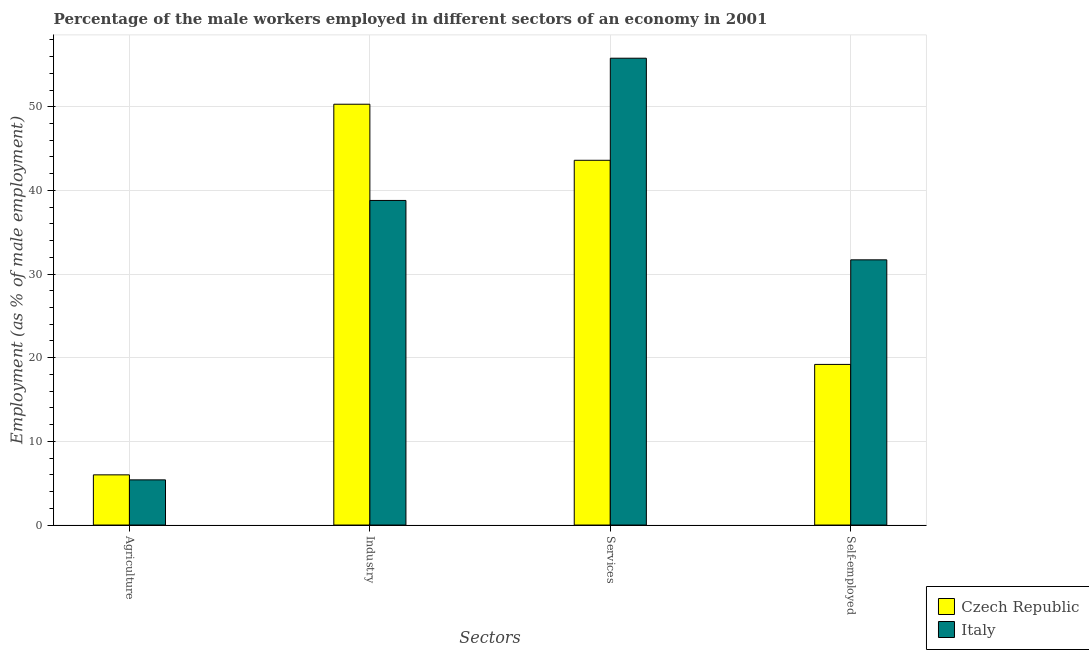How many different coloured bars are there?
Your answer should be very brief. 2. How many groups of bars are there?
Your response must be concise. 4. Are the number of bars per tick equal to the number of legend labels?
Keep it short and to the point. Yes. Are the number of bars on each tick of the X-axis equal?
Your response must be concise. Yes. How many bars are there on the 4th tick from the left?
Your answer should be very brief. 2. What is the label of the 2nd group of bars from the left?
Your answer should be very brief. Industry. What is the percentage of male workers in services in Italy?
Provide a succinct answer. 55.8. Across all countries, what is the maximum percentage of self employed male workers?
Offer a terse response. 31.7. Across all countries, what is the minimum percentage of male workers in agriculture?
Provide a short and direct response. 5.4. In which country was the percentage of male workers in services maximum?
Ensure brevity in your answer.  Italy. In which country was the percentage of male workers in agriculture minimum?
Your answer should be very brief. Italy. What is the total percentage of male workers in services in the graph?
Provide a succinct answer. 99.4. What is the difference between the percentage of male workers in industry in Italy and that in Czech Republic?
Your response must be concise. -11.5. What is the difference between the percentage of male workers in agriculture in Italy and the percentage of self employed male workers in Czech Republic?
Your answer should be very brief. -13.8. What is the average percentage of male workers in services per country?
Make the answer very short. 49.7. What is the difference between the percentage of male workers in industry and percentage of self employed male workers in Italy?
Provide a short and direct response. 7.1. In how many countries, is the percentage of male workers in services greater than 24 %?
Offer a terse response. 2. What is the ratio of the percentage of male workers in industry in Czech Republic to that in Italy?
Your response must be concise. 1.3. Is the percentage of male workers in agriculture in Czech Republic less than that in Italy?
Your response must be concise. No. Is the difference between the percentage of self employed male workers in Czech Republic and Italy greater than the difference between the percentage of male workers in services in Czech Republic and Italy?
Ensure brevity in your answer.  No. What is the difference between the highest and the second highest percentage of male workers in services?
Provide a short and direct response. 12.2. What is the difference between the highest and the lowest percentage of male workers in industry?
Offer a very short reply. 11.5. In how many countries, is the percentage of self employed male workers greater than the average percentage of self employed male workers taken over all countries?
Make the answer very short. 1. What does the 1st bar from the left in Industry represents?
Make the answer very short. Czech Republic. Is it the case that in every country, the sum of the percentage of male workers in agriculture and percentage of male workers in industry is greater than the percentage of male workers in services?
Your answer should be compact. No. How many bars are there?
Offer a very short reply. 8. Are all the bars in the graph horizontal?
Provide a short and direct response. No. How many countries are there in the graph?
Keep it short and to the point. 2. What is the difference between two consecutive major ticks on the Y-axis?
Your answer should be very brief. 10. Does the graph contain any zero values?
Your response must be concise. No. How are the legend labels stacked?
Offer a very short reply. Vertical. What is the title of the graph?
Keep it short and to the point. Percentage of the male workers employed in different sectors of an economy in 2001. Does "St. Lucia" appear as one of the legend labels in the graph?
Make the answer very short. No. What is the label or title of the X-axis?
Give a very brief answer. Sectors. What is the label or title of the Y-axis?
Your answer should be very brief. Employment (as % of male employment). What is the Employment (as % of male employment) of Italy in Agriculture?
Provide a succinct answer. 5.4. What is the Employment (as % of male employment) of Czech Republic in Industry?
Keep it short and to the point. 50.3. What is the Employment (as % of male employment) in Italy in Industry?
Offer a terse response. 38.8. What is the Employment (as % of male employment) in Czech Republic in Services?
Provide a short and direct response. 43.6. What is the Employment (as % of male employment) of Italy in Services?
Offer a terse response. 55.8. What is the Employment (as % of male employment) of Czech Republic in Self-employed?
Offer a very short reply. 19.2. What is the Employment (as % of male employment) in Italy in Self-employed?
Keep it short and to the point. 31.7. Across all Sectors, what is the maximum Employment (as % of male employment) of Czech Republic?
Offer a very short reply. 50.3. Across all Sectors, what is the maximum Employment (as % of male employment) in Italy?
Make the answer very short. 55.8. Across all Sectors, what is the minimum Employment (as % of male employment) in Italy?
Offer a terse response. 5.4. What is the total Employment (as % of male employment) in Czech Republic in the graph?
Provide a succinct answer. 119.1. What is the total Employment (as % of male employment) in Italy in the graph?
Ensure brevity in your answer.  131.7. What is the difference between the Employment (as % of male employment) in Czech Republic in Agriculture and that in Industry?
Provide a short and direct response. -44.3. What is the difference between the Employment (as % of male employment) of Italy in Agriculture and that in Industry?
Offer a very short reply. -33.4. What is the difference between the Employment (as % of male employment) in Czech Republic in Agriculture and that in Services?
Offer a very short reply. -37.6. What is the difference between the Employment (as % of male employment) in Italy in Agriculture and that in Services?
Your answer should be compact. -50.4. What is the difference between the Employment (as % of male employment) of Czech Republic in Agriculture and that in Self-employed?
Offer a very short reply. -13.2. What is the difference between the Employment (as % of male employment) of Italy in Agriculture and that in Self-employed?
Offer a terse response. -26.3. What is the difference between the Employment (as % of male employment) in Czech Republic in Industry and that in Services?
Give a very brief answer. 6.7. What is the difference between the Employment (as % of male employment) in Czech Republic in Industry and that in Self-employed?
Ensure brevity in your answer.  31.1. What is the difference between the Employment (as % of male employment) in Czech Republic in Services and that in Self-employed?
Offer a very short reply. 24.4. What is the difference between the Employment (as % of male employment) in Italy in Services and that in Self-employed?
Offer a very short reply. 24.1. What is the difference between the Employment (as % of male employment) of Czech Republic in Agriculture and the Employment (as % of male employment) of Italy in Industry?
Provide a short and direct response. -32.8. What is the difference between the Employment (as % of male employment) in Czech Republic in Agriculture and the Employment (as % of male employment) in Italy in Services?
Your answer should be very brief. -49.8. What is the difference between the Employment (as % of male employment) of Czech Republic in Agriculture and the Employment (as % of male employment) of Italy in Self-employed?
Keep it short and to the point. -25.7. What is the difference between the Employment (as % of male employment) of Czech Republic in Services and the Employment (as % of male employment) of Italy in Self-employed?
Provide a succinct answer. 11.9. What is the average Employment (as % of male employment) in Czech Republic per Sectors?
Your response must be concise. 29.77. What is the average Employment (as % of male employment) of Italy per Sectors?
Offer a very short reply. 32.92. What is the difference between the Employment (as % of male employment) in Czech Republic and Employment (as % of male employment) in Italy in Agriculture?
Your answer should be compact. 0.6. What is the difference between the Employment (as % of male employment) of Czech Republic and Employment (as % of male employment) of Italy in Services?
Offer a terse response. -12.2. What is the ratio of the Employment (as % of male employment) of Czech Republic in Agriculture to that in Industry?
Offer a terse response. 0.12. What is the ratio of the Employment (as % of male employment) in Italy in Agriculture to that in Industry?
Provide a succinct answer. 0.14. What is the ratio of the Employment (as % of male employment) of Czech Republic in Agriculture to that in Services?
Provide a succinct answer. 0.14. What is the ratio of the Employment (as % of male employment) of Italy in Agriculture to that in Services?
Ensure brevity in your answer.  0.1. What is the ratio of the Employment (as % of male employment) in Czech Republic in Agriculture to that in Self-employed?
Provide a short and direct response. 0.31. What is the ratio of the Employment (as % of male employment) in Italy in Agriculture to that in Self-employed?
Offer a terse response. 0.17. What is the ratio of the Employment (as % of male employment) in Czech Republic in Industry to that in Services?
Offer a very short reply. 1.15. What is the ratio of the Employment (as % of male employment) of Italy in Industry to that in Services?
Keep it short and to the point. 0.7. What is the ratio of the Employment (as % of male employment) in Czech Republic in Industry to that in Self-employed?
Offer a terse response. 2.62. What is the ratio of the Employment (as % of male employment) of Italy in Industry to that in Self-employed?
Your answer should be compact. 1.22. What is the ratio of the Employment (as % of male employment) of Czech Republic in Services to that in Self-employed?
Give a very brief answer. 2.27. What is the ratio of the Employment (as % of male employment) of Italy in Services to that in Self-employed?
Your response must be concise. 1.76. What is the difference between the highest and the second highest Employment (as % of male employment) in Czech Republic?
Provide a short and direct response. 6.7. What is the difference between the highest and the second highest Employment (as % of male employment) of Italy?
Make the answer very short. 17. What is the difference between the highest and the lowest Employment (as % of male employment) in Czech Republic?
Give a very brief answer. 44.3. What is the difference between the highest and the lowest Employment (as % of male employment) of Italy?
Your answer should be compact. 50.4. 